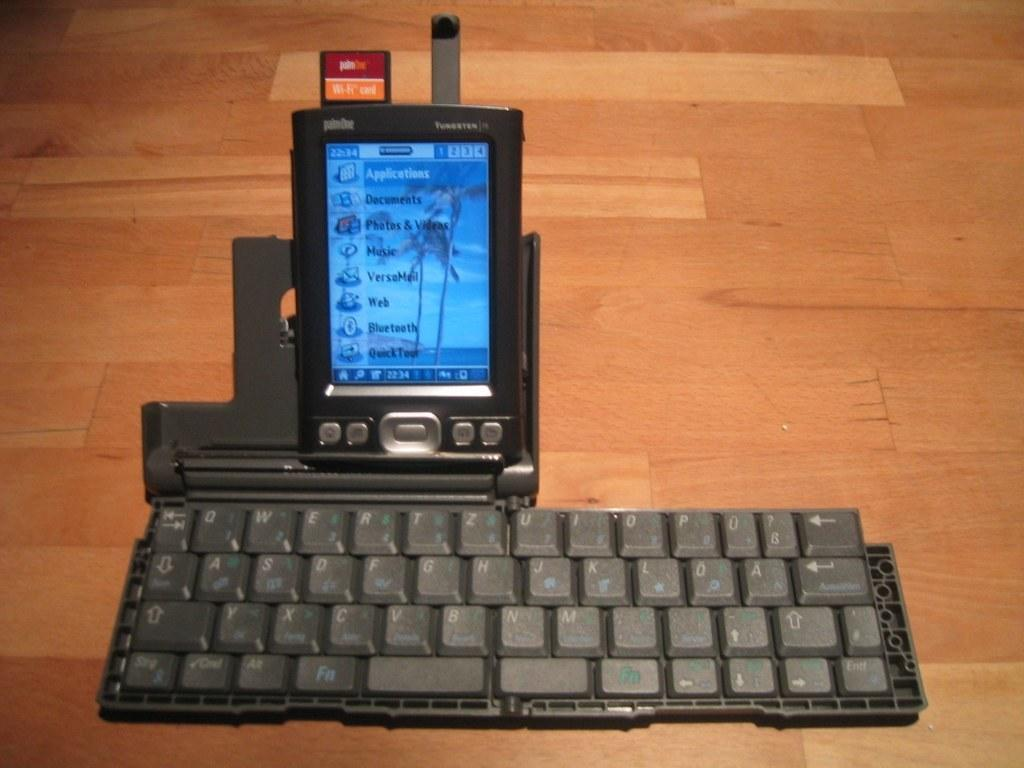<image>
Describe the image concisely. a Palm One gadget sits on a keyboard and a wooden floor 